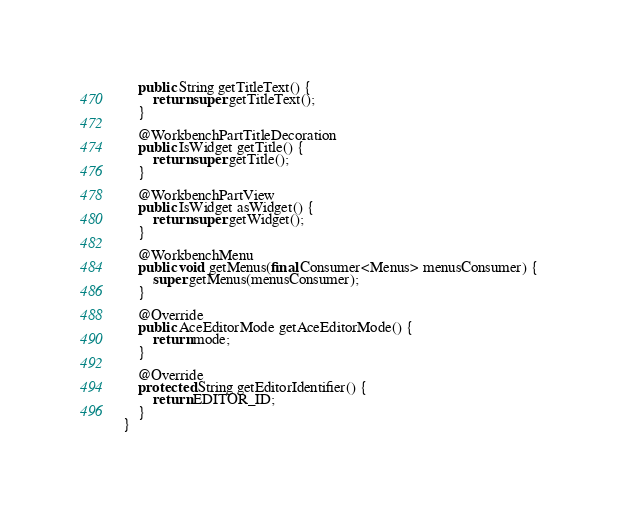Convert code to text. <code><loc_0><loc_0><loc_500><loc_500><_Java_>    public String getTitleText() {
        return super.getTitleText();
    }

    @WorkbenchPartTitleDecoration
    public IsWidget getTitle() {
        return super.getTitle();
    }

    @WorkbenchPartView
    public IsWidget asWidget() {
        return super.getWidget();
    }

    @WorkbenchMenu
    public void getMenus(final Consumer<Menus> menusConsumer) {
        super.getMenus(menusConsumer);
    }

    @Override
    public AceEditorMode getAceEditorMode() {
        return mode;
    }

    @Override
    protected String getEditorIdentifier() {
        return EDITOR_ID;
    }
}
</code> 